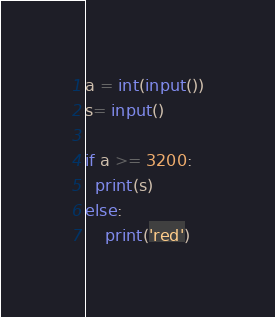Convert code to text. <code><loc_0><loc_0><loc_500><loc_500><_Python_>a = int(input())
s= input()

if a >= 3200:
  print(s)
else:
    print('red')</code> 